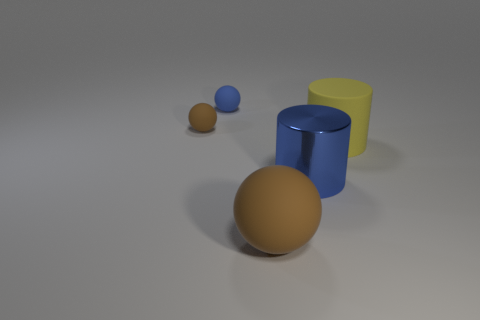Are there fewer blue objects than tiny blue matte things?
Give a very brief answer. No. There is a matte object that is in front of the blue rubber sphere and behind the large yellow matte object; what is its size?
Your answer should be compact. Small. Do the yellow object and the blue rubber sphere have the same size?
Provide a succinct answer. No. There is a tiny matte ball left of the small blue rubber ball; is its color the same as the matte cylinder?
Provide a succinct answer. No. How many tiny matte objects are in front of the big shiny thing?
Provide a short and direct response. 0. Is the number of objects greater than the number of tiny brown rubber things?
Ensure brevity in your answer.  Yes. What shape is the thing that is both right of the large sphere and behind the big blue object?
Your response must be concise. Cylinder. Is there a tiny metallic cylinder?
Offer a very short reply. No. What is the material of the blue object that is the same shape as the yellow matte object?
Ensure brevity in your answer.  Metal. The blue object that is in front of the brown rubber thing that is left of the brown rubber sphere that is in front of the big yellow object is what shape?
Give a very brief answer. Cylinder. 